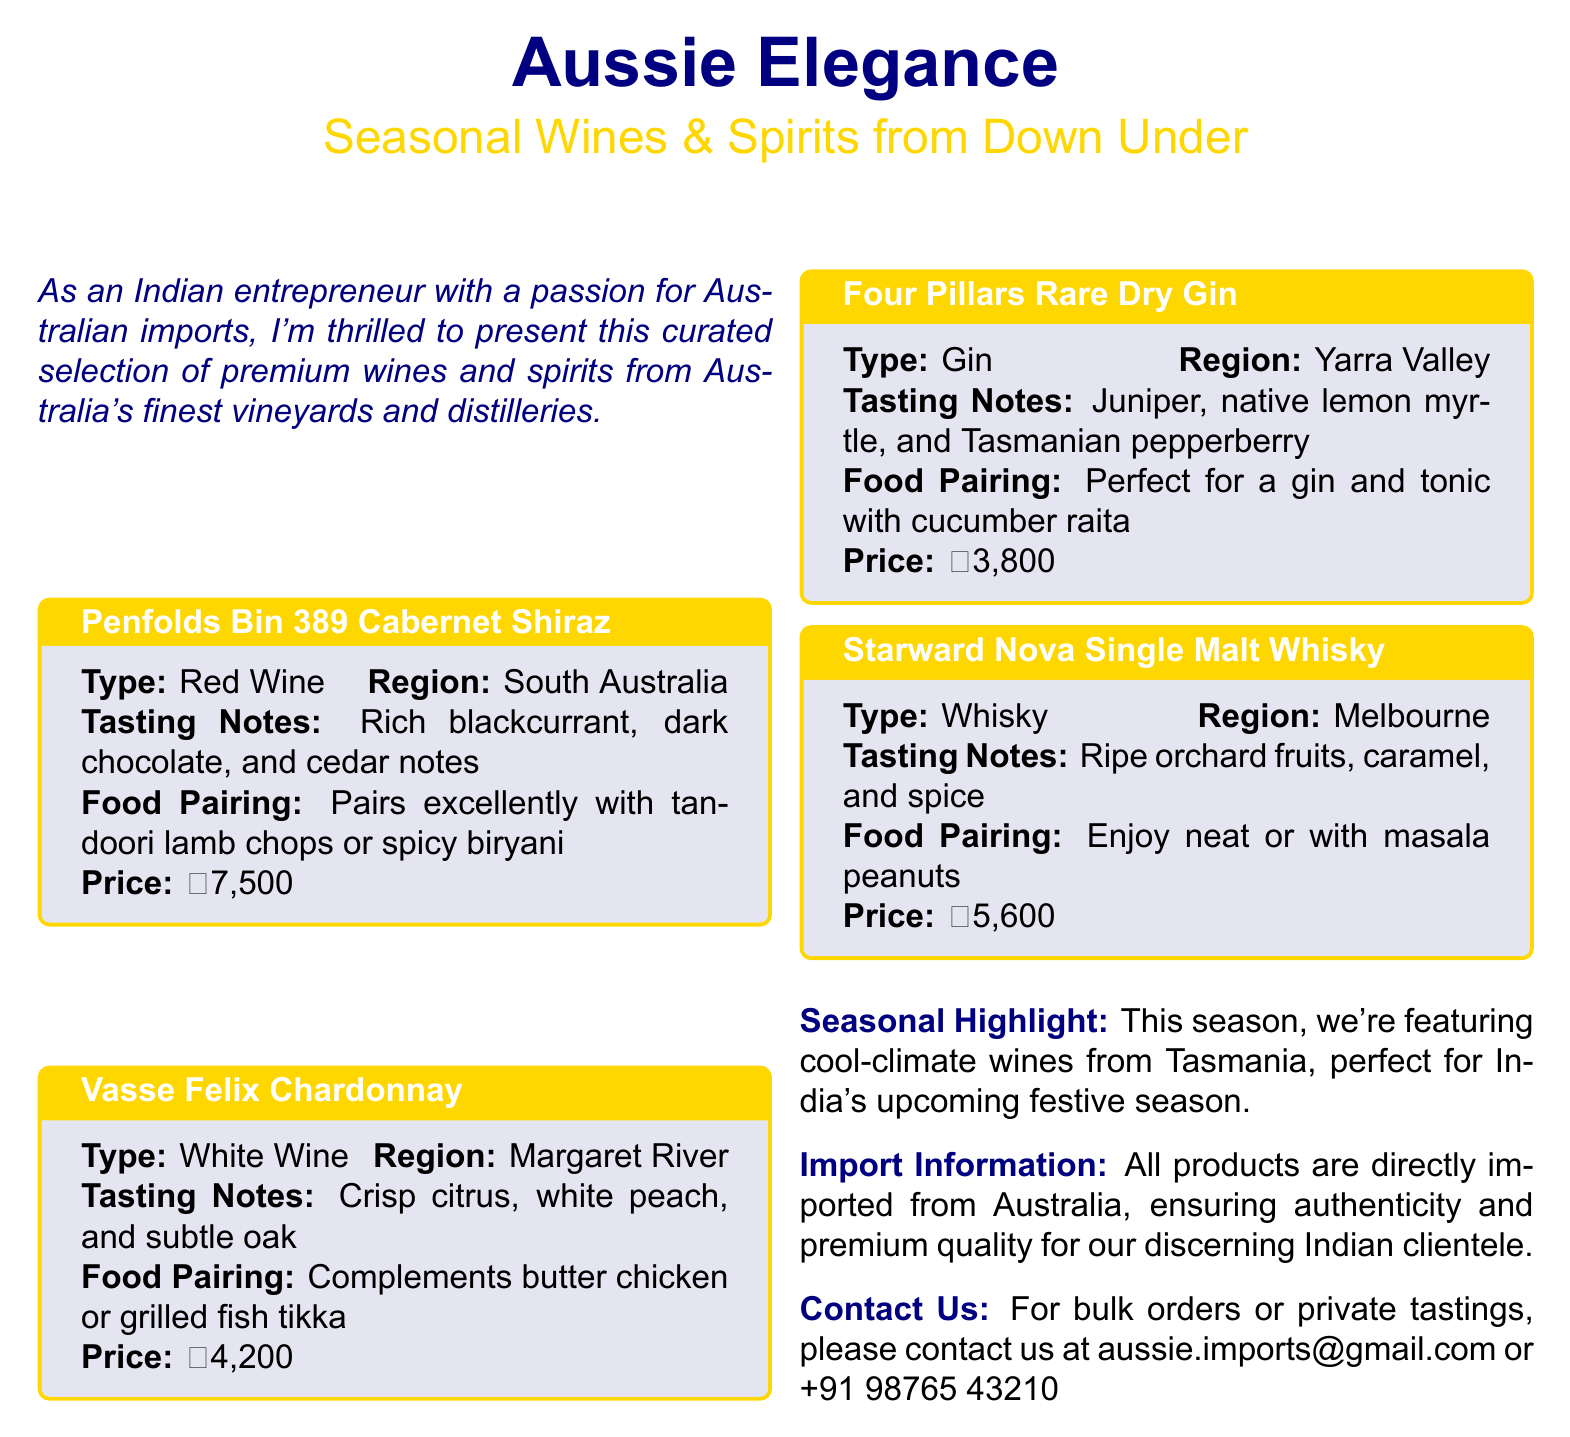What wine is priced at ₹7,500? The document lists Penfolds Bin 389 Cabernet Shiraz with a price of ₹7,500.
Answer: Penfolds Bin 389 Cabernet Shiraz What is the region of Vasse Felix Chardonnay? The document states that Vasse Felix Chardonnay originates from Margaret River.
Answer: Margaret River Which spirit is suggested to pair with cucumber raita? The document mentions Four Pillars Rare Dry Gin as perfect for pairing with cucumber raita.
Answer: Four Pillars Rare Dry Gin What is the total number of wines and spirits listed? There are four products displayed in the document: two wines and two spirits.
Answer: Four What unique feature is highlighted for this season? The document points out the selection of cool-climate wines from Tasmania as a seasonal highlight.
Answer: Cool-climate wines from Tasmania What food pairs excellently with Starward Nova Single Malt Whisky? The pairing suggestion for Starward Nova Single Malt Whisky is to enjoy it with masala peanuts.
Answer: Masala peanuts What is the main contact email for bulk orders? The document provides the email address aussie.imports@gmail.com for contacting regarding bulk orders.
Answer: aussie.imports@gmail.com What color are the tasting notes presented in? The tasting notes are presented in a text color defined as aussienavy.
Answer: Aussienavy 